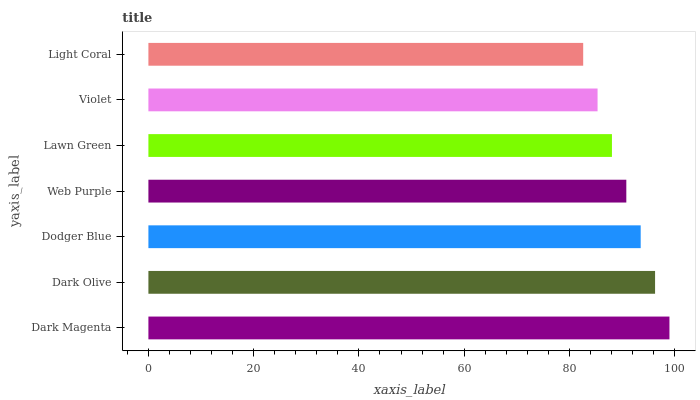Is Light Coral the minimum?
Answer yes or no. Yes. Is Dark Magenta the maximum?
Answer yes or no. Yes. Is Dark Olive the minimum?
Answer yes or no. No. Is Dark Olive the maximum?
Answer yes or no. No. Is Dark Magenta greater than Dark Olive?
Answer yes or no. Yes. Is Dark Olive less than Dark Magenta?
Answer yes or no. Yes. Is Dark Olive greater than Dark Magenta?
Answer yes or no. No. Is Dark Magenta less than Dark Olive?
Answer yes or no. No. Is Web Purple the high median?
Answer yes or no. Yes. Is Web Purple the low median?
Answer yes or no. Yes. Is Lawn Green the high median?
Answer yes or no. No. Is Dodger Blue the low median?
Answer yes or no. No. 